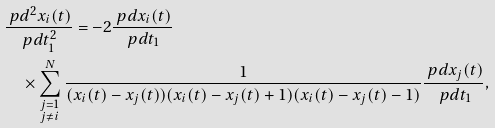<formula> <loc_0><loc_0><loc_500><loc_500>& \frac { \ p d ^ { 2 } x _ { i } ( t ) } { \ p d t _ { 1 } ^ { 2 } } = - 2 \frac { \ p d x _ { i } ( t ) } { \ p d t _ { 1 } } \\ & \quad \times \sum _ { \begin{subarray} { c } j = 1 \\ j \neq i \end{subarray} } ^ { N } \frac { 1 } { ( x _ { i } ( t ) - x _ { j } ( t ) ) ( x _ { i } ( t ) - x _ { j } ( t ) + 1 ) ( x _ { i } ( t ) - x _ { j } ( t ) - 1 ) } \frac { \ p d x _ { j } ( t ) } { \ p d t _ { 1 } } ,</formula> 